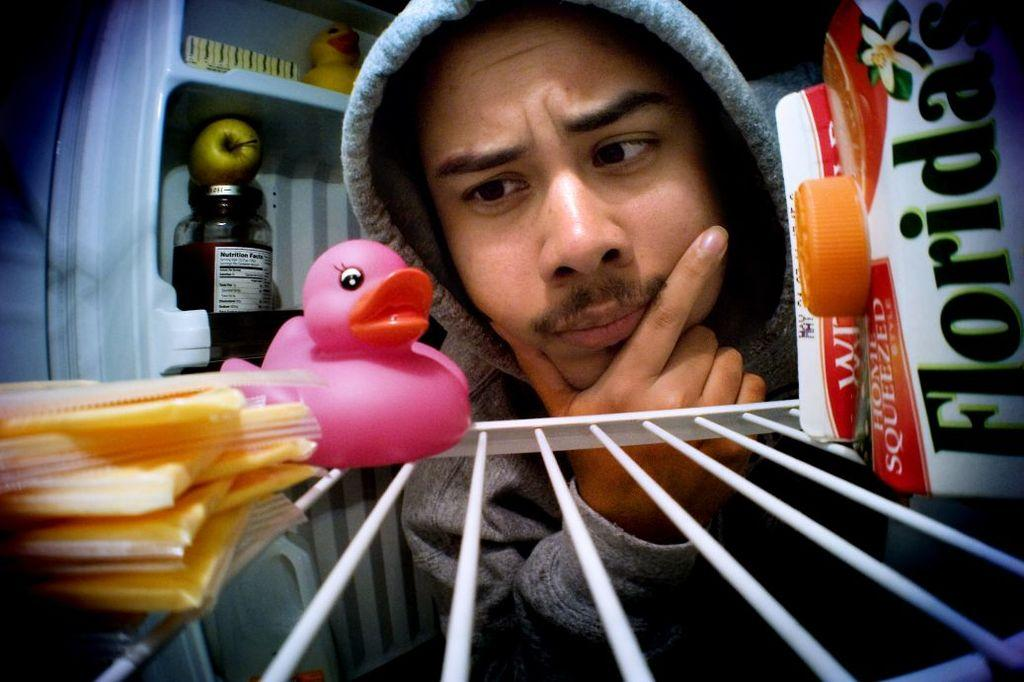What is the main object in the image with a cap? There is a box with a cap in the image. What type of object is the toy in the image? There is a toy in the image, but the specific type is not mentioned. Where are the objects on the rack located? The objects on the rack are located in shelves in the image. What is inside the jar in the image? The facts do not specify what is inside the jar. What fruit is present in the image? There is an apple in the image. How many toys are visible in the image? There are two toys visible in the image. What type of toothpaste is being used by the man in the image? There is no man using toothpaste in the image. What is the hall like in the image? There is no mention of a hall in the image. 